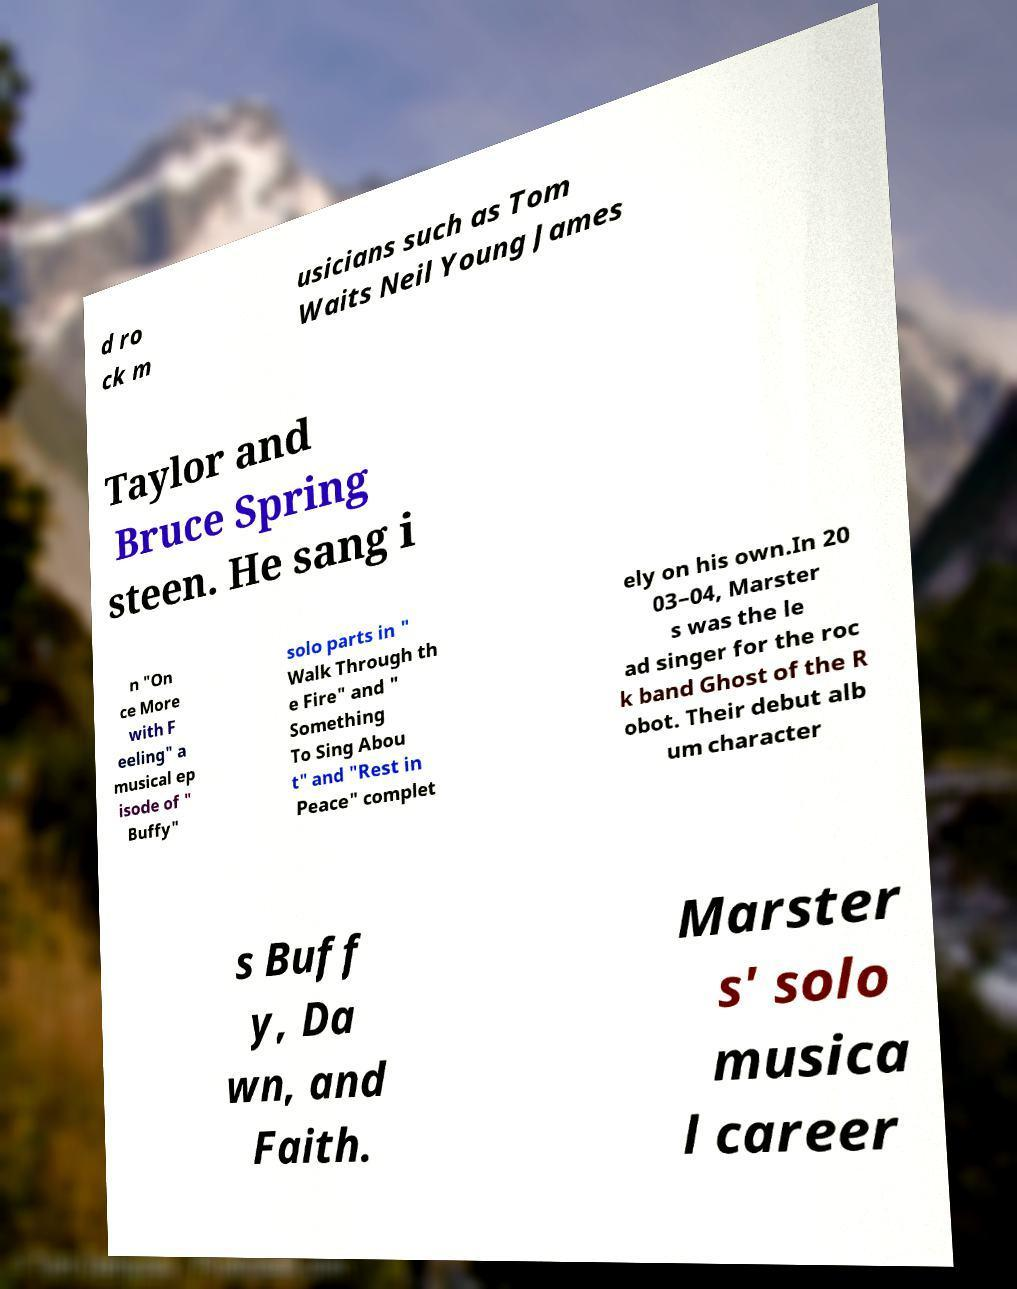Please identify and transcribe the text found in this image. d ro ck m usicians such as Tom Waits Neil Young James Taylor and Bruce Spring steen. He sang i n "On ce More with F eeling" a musical ep isode of " Buffy" solo parts in " Walk Through th e Fire" and " Something To Sing Abou t" and "Rest in Peace" complet ely on his own.In 20 03–04, Marster s was the le ad singer for the roc k band Ghost of the R obot. Their debut alb um character s Buff y, Da wn, and Faith. Marster s' solo musica l career 